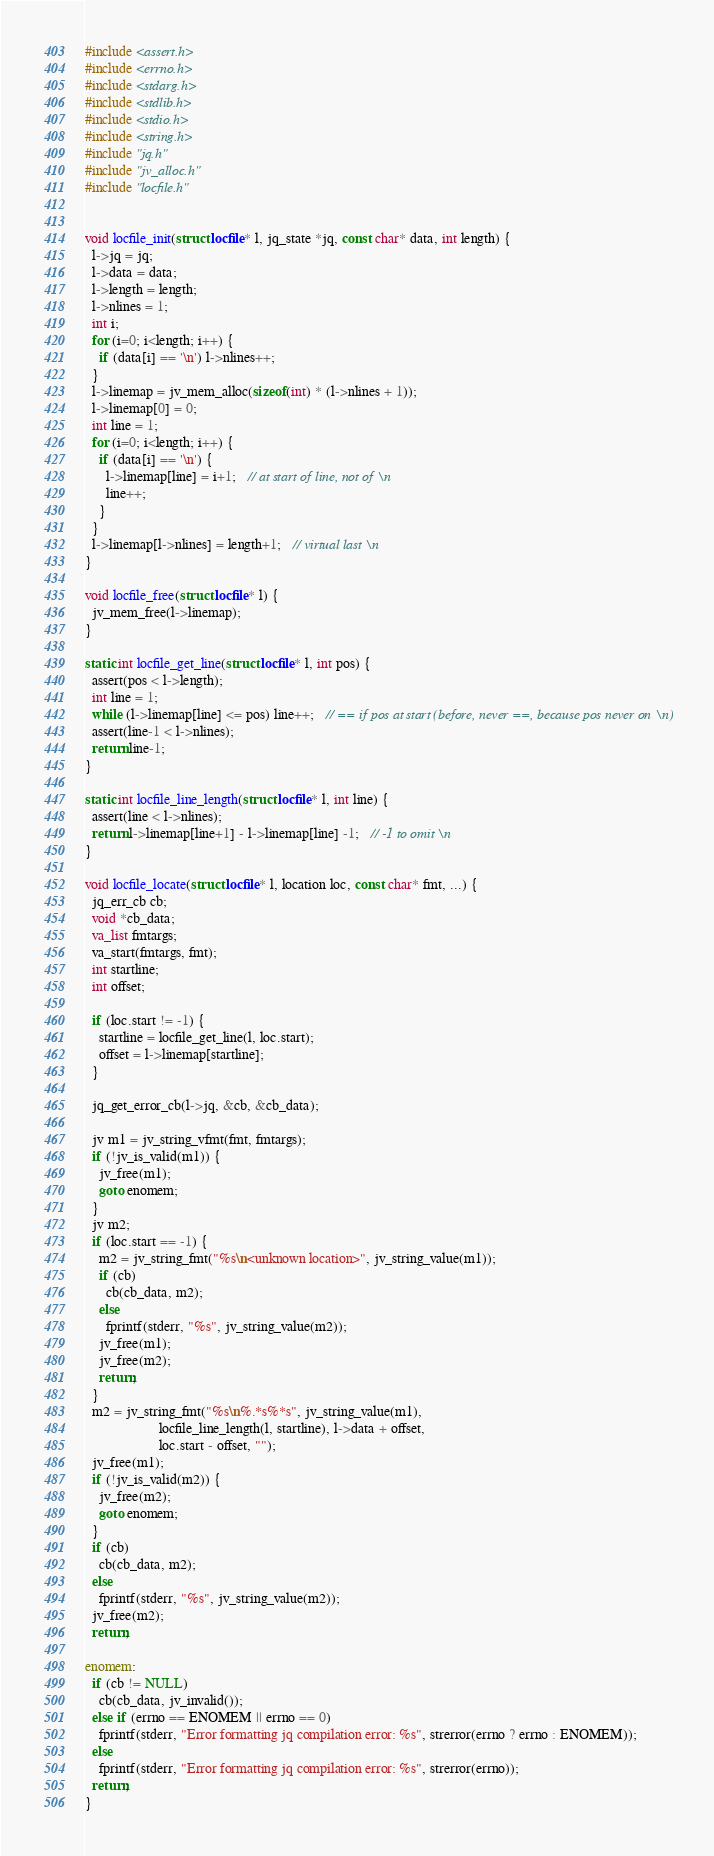<code> <loc_0><loc_0><loc_500><loc_500><_C_>#include <assert.h>
#include <errno.h>
#include <stdarg.h>
#include <stdlib.h>
#include <stdio.h>
#include <string.h>
#include "jq.h"
#include "jv_alloc.h"
#include "locfile.h"


void locfile_init(struct locfile* l, jq_state *jq, const char* data, int length) {
  l->jq = jq;
  l->data = data;
  l->length = length;
  l->nlines = 1;
  int i;
  for (i=0; i<length; i++) {
    if (data[i] == '\n') l->nlines++;
  }
  l->linemap = jv_mem_alloc(sizeof(int) * (l->nlines + 1));
  l->linemap[0] = 0;
  int line = 1;
  for (i=0; i<length; i++) {
    if (data[i] == '\n') {
      l->linemap[line] = i+1;   // at start of line, not of \n
      line++;
    }
  }
  l->linemap[l->nlines] = length+1;   // virtual last \n
}

void locfile_free(struct locfile* l) {
  jv_mem_free(l->linemap);
}

static int locfile_get_line(struct locfile* l, int pos) {
  assert(pos < l->length);
  int line = 1;
  while (l->linemap[line] <= pos) line++;   // == if pos at start (before, never ==, because pos never on \n)
  assert(line-1 < l->nlines);
  return line-1;
}

static int locfile_line_length(struct locfile* l, int line) {
  assert(line < l->nlines);
  return l->linemap[line+1] - l->linemap[line] -1;   // -1 to omit \n
}

void locfile_locate(struct locfile* l, location loc, const char* fmt, ...) {
  jq_err_cb cb;
  void *cb_data;
  va_list fmtargs;
  va_start(fmtargs, fmt);
  int startline;
  int offset;

  if (loc.start != -1) {
    startline = locfile_get_line(l, loc.start);
    offset = l->linemap[startline];
  }

  jq_get_error_cb(l->jq, &cb, &cb_data);

  jv m1 = jv_string_vfmt(fmt, fmtargs);
  if (!jv_is_valid(m1)) {
    jv_free(m1);
    goto enomem;
  }
  jv m2;
  if (loc.start == -1) {
    m2 = jv_string_fmt("%s\n<unknown location>", jv_string_value(m1));
    if (cb)
      cb(cb_data, m2);
    else
      fprintf(stderr, "%s", jv_string_value(m2));
    jv_free(m1);
    jv_free(m2);
    return;
  }
  m2 = jv_string_fmt("%s\n%.*s%*s", jv_string_value(m1),
                     locfile_line_length(l, startline), l->data + offset,
                     loc.start - offset, "");
  jv_free(m1);
  if (!jv_is_valid(m2)) {
    jv_free(m2);
    goto enomem;
  }
  if (cb)
    cb(cb_data, m2);
  else
    fprintf(stderr, "%s", jv_string_value(m2));
  jv_free(m2);
  return;

enomem:
  if (cb != NULL)
    cb(cb_data, jv_invalid());
  else if (errno == ENOMEM || errno == 0)
    fprintf(stderr, "Error formatting jq compilation error: %s", strerror(errno ? errno : ENOMEM));
  else
    fprintf(stderr, "Error formatting jq compilation error: %s", strerror(errno));
  return;
}
</code> 